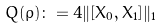<formula> <loc_0><loc_0><loc_500><loc_500>Q ( \rho ) \colon = 4 \| [ X _ { 0 } , X _ { 1 } ] \| _ { 1 }</formula> 